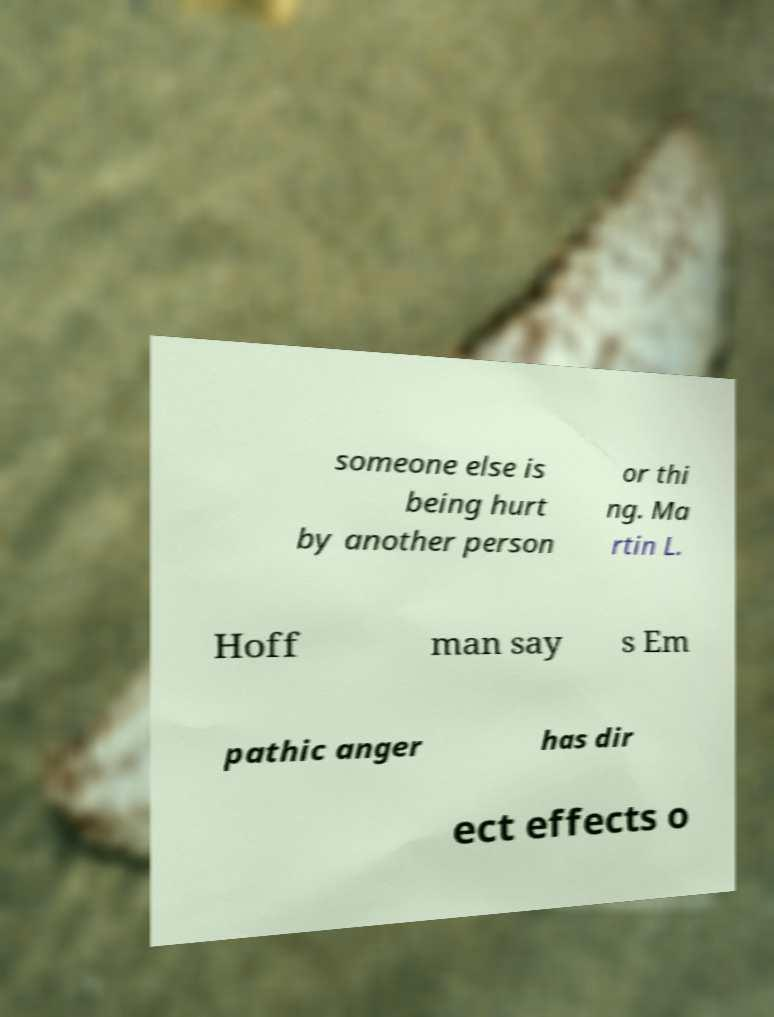Can you accurately transcribe the text from the provided image for me? someone else is being hurt by another person or thi ng. Ma rtin L. Hoff man say s Em pathic anger has dir ect effects o 